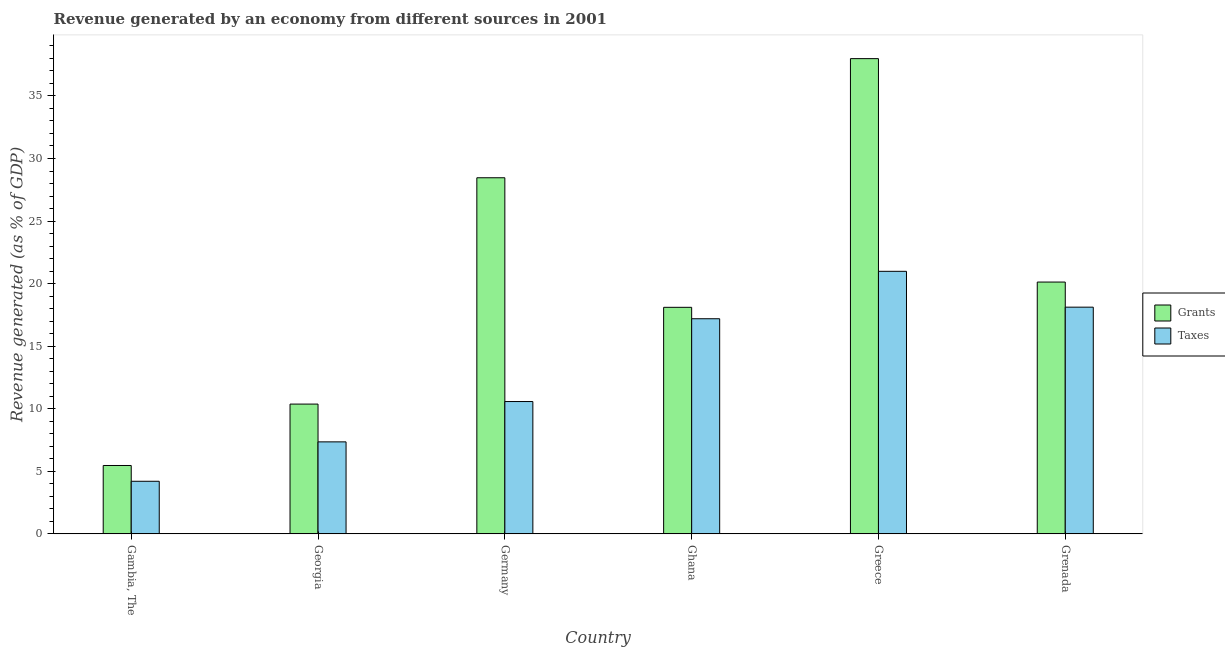How many different coloured bars are there?
Keep it short and to the point. 2. How many groups of bars are there?
Your answer should be very brief. 6. Are the number of bars per tick equal to the number of legend labels?
Make the answer very short. Yes. How many bars are there on the 5th tick from the left?
Provide a short and direct response. 2. How many bars are there on the 4th tick from the right?
Provide a succinct answer. 2. What is the label of the 5th group of bars from the left?
Your answer should be very brief. Greece. In how many cases, is the number of bars for a given country not equal to the number of legend labels?
Offer a terse response. 0. What is the revenue generated by grants in Grenada?
Offer a terse response. 20.13. Across all countries, what is the maximum revenue generated by taxes?
Offer a very short reply. 20.98. Across all countries, what is the minimum revenue generated by taxes?
Your answer should be very brief. 4.2. In which country was the revenue generated by taxes maximum?
Offer a very short reply. Greece. In which country was the revenue generated by taxes minimum?
Offer a terse response. Gambia, The. What is the total revenue generated by taxes in the graph?
Keep it short and to the point. 78.43. What is the difference between the revenue generated by taxes in Gambia, The and that in Germany?
Ensure brevity in your answer.  -6.37. What is the difference between the revenue generated by grants in Grenada and the revenue generated by taxes in Greece?
Provide a short and direct response. -0.86. What is the average revenue generated by grants per country?
Provide a succinct answer. 20.08. What is the difference between the revenue generated by taxes and revenue generated by grants in Greece?
Offer a terse response. -17. In how many countries, is the revenue generated by grants greater than 3 %?
Ensure brevity in your answer.  6. What is the ratio of the revenue generated by grants in Gambia, The to that in Georgia?
Keep it short and to the point. 0.53. What is the difference between the highest and the second highest revenue generated by grants?
Give a very brief answer. 9.52. What is the difference between the highest and the lowest revenue generated by taxes?
Keep it short and to the point. 16.78. Is the sum of the revenue generated by taxes in Greece and Grenada greater than the maximum revenue generated by grants across all countries?
Offer a terse response. Yes. What does the 1st bar from the left in Germany represents?
Provide a short and direct response. Grants. What does the 1st bar from the right in Grenada represents?
Your answer should be compact. Taxes. How many bars are there?
Offer a terse response. 12. How many countries are there in the graph?
Provide a succinct answer. 6. What is the difference between two consecutive major ticks on the Y-axis?
Give a very brief answer. 5. Does the graph contain any zero values?
Your answer should be very brief. No. What is the title of the graph?
Offer a terse response. Revenue generated by an economy from different sources in 2001. Does "Commercial service exports" appear as one of the legend labels in the graph?
Provide a succinct answer. No. What is the label or title of the Y-axis?
Offer a very short reply. Revenue generated (as % of GDP). What is the Revenue generated (as % of GDP) of Grants in Gambia, The?
Offer a very short reply. 5.46. What is the Revenue generated (as % of GDP) in Taxes in Gambia, The?
Provide a short and direct response. 4.2. What is the Revenue generated (as % of GDP) of Grants in Georgia?
Provide a short and direct response. 10.37. What is the Revenue generated (as % of GDP) in Taxes in Georgia?
Your answer should be compact. 7.35. What is the Revenue generated (as % of GDP) of Grants in Germany?
Offer a very short reply. 28.46. What is the Revenue generated (as % of GDP) of Taxes in Germany?
Your answer should be very brief. 10.58. What is the Revenue generated (as % of GDP) of Grants in Ghana?
Your answer should be very brief. 18.11. What is the Revenue generated (as % of GDP) of Taxes in Ghana?
Make the answer very short. 17.19. What is the Revenue generated (as % of GDP) in Grants in Greece?
Provide a short and direct response. 37.98. What is the Revenue generated (as % of GDP) in Taxes in Greece?
Provide a short and direct response. 20.98. What is the Revenue generated (as % of GDP) of Grants in Grenada?
Make the answer very short. 20.13. What is the Revenue generated (as % of GDP) of Taxes in Grenada?
Offer a very short reply. 18.12. Across all countries, what is the maximum Revenue generated (as % of GDP) in Grants?
Offer a very short reply. 37.98. Across all countries, what is the maximum Revenue generated (as % of GDP) of Taxes?
Give a very brief answer. 20.98. Across all countries, what is the minimum Revenue generated (as % of GDP) in Grants?
Your answer should be very brief. 5.46. Across all countries, what is the minimum Revenue generated (as % of GDP) in Taxes?
Offer a terse response. 4.2. What is the total Revenue generated (as % of GDP) of Grants in the graph?
Offer a terse response. 120.51. What is the total Revenue generated (as % of GDP) in Taxes in the graph?
Make the answer very short. 78.43. What is the difference between the Revenue generated (as % of GDP) of Grants in Gambia, The and that in Georgia?
Offer a very short reply. -4.91. What is the difference between the Revenue generated (as % of GDP) in Taxes in Gambia, The and that in Georgia?
Your response must be concise. -3.15. What is the difference between the Revenue generated (as % of GDP) in Grants in Gambia, The and that in Germany?
Your answer should be compact. -23. What is the difference between the Revenue generated (as % of GDP) in Taxes in Gambia, The and that in Germany?
Keep it short and to the point. -6.37. What is the difference between the Revenue generated (as % of GDP) in Grants in Gambia, The and that in Ghana?
Provide a short and direct response. -12.64. What is the difference between the Revenue generated (as % of GDP) of Taxes in Gambia, The and that in Ghana?
Provide a short and direct response. -12.99. What is the difference between the Revenue generated (as % of GDP) of Grants in Gambia, The and that in Greece?
Offer a very short reply. -32.52. What is the difference between the Revenue generated (as % of GDP) of Taxes in Gambia, The and that in Greece?
Your answer should be very brief. -16.78. What is the difference between the Revenue generated (as % of GDP) of Grants in Gambia, The and that in Grenada?
Provide a succinct answer. -14.66. What is the difference between the Revenue generated (as % of GDP) in Taxes in Gambia, The and that in Grenada?
Your answer should be compact. -13.91. What is the difference between the Revenue generated (as % of GDP) of Grants in Georgia and that in Germany?
Offer a terse response. -18.09. What is the difference between the Revenue generated (as % of GDP) in Taxes in Georgia and that in Germany?
Your response must be concise. -3.22. What is the difference between the Revenue generated (as % of GDP) in Grants in Georgia and that in Ghana?
Ensure brevity in your answer.  -7.73. What is the difference between the Revenue generated (as % of GDP) in Taxes in Georgia and that in Ghana?
Offer a terse response. -9.84. What is the difference between the Revenue generated (as % of GDP) of Grants in Georgia and that in Greece?
Your response must be concise. -27.61. What is the difference between the Revenue generated (as % of GDP) of Taxes in Georgia and that in Greece?
Your answer should be very brief. -13.63. What is the difference between the Revenue generated (as % of GDP) of Grants in Georgia and that in Grenada?
Give a very brief answer. -9.75. What is the difference between the Revenue generated (as % of GDP) in Taxes in Georgia and that in Grenada?
Offer a terse response. -10.77. What is the difference between the Revenue generated (as % of GDP) of Grants in Germany and that in Ghana?
Offer a terse response. 10.35. What is the difference between the Revenue generated (as % of GDP) of Taxes in Germany and that in Ghana?
Your response must be concise. -6.62. What is the difference between the Revenue generated (as % of GDP) of Grants in Germany and that in Greece?
Your answer should be compact. -9.52. What is the difference between the Revenue generated (as % of GDP) in Taxes in Germany and that in Greece?
Provide a short and direct response. -10.41. What is the difference between the Revenue generated (as % of GDP) in Grants in Germany and that in Grenada?
Your answer should be compact. 8.34. What is the difference between the Revenue generated (as % of GDP) of Taxes in Germany and that in Grenada?
Offer a terse response. -7.54. What is the difference between the Revenue generated (as % of GDP) of Grants in Ghana and that in Greece?
Your answer should be compact. -19.88. What is the difference between the Revenue generated (as % of GDP) in Taxes in Ghana and that in Greece?
Offer a very short reply. -3.79. What is the difference between the Revenue generated (as % of GDP) of Grants in Ghana and that in Grenada?
Your answer should be very brief. -2.02. What is the difference between the Revenue generated (as % of GDP) in Taxes in Ghana and that in Grenada?
Your answer should be compact. -0.93. What is the difference between the Revenue generated (as % of GDP) in Grants in Greece and that in Grenada?
Keep it short and to the point. 17.86. What is the difference between the Revenue generated (as % of GDP) of Taxes in Greece and that in Grenada?
Your answer should be very brief. 2.86. What is the difference between the Revenue generated (as % of GDP) of Grants in Gambia, The and the Revenue generated (as % of GDP) of Taxes in Georgia?
Ensure brevity in your answer.  -1.89. What is the difference between the Revenue generated (as % of GDP) in Grants in Gambia, The and the Revenue generated (as % of GDP) in Taxes in Germany?
Provide a short and direct response. -5.11. What is the difference between the Revenue generated (as % of GDP) of Grants in Gambia, The and the Revenue generated (as % of GDP) of Taxes in Ghana?
Provide a short and direct response. -11.73. What is the difference between the Revenue generated (as % of GDP) in Grants in Gambia, The and the Revenue generated (as % of GDP) in Taxes in Greece?
Keep it short and to the point. -15.52. What is the difference between the Revenue generated (as % of GDP) of Grants in Gambia, The and the Revenue generated (as % of GDP) of Taxes in Grenada?
Ensure brevity in your answer.  -12.65. What is the difference between the Revenue generated (as % of GDP) of Grants in Georgia and the Revenue generated (as % of GDP) of Taxes in Germany?
Offer a very short reply. -0.2. What is the difference between the Revenue generated (as % of GDP) in Grants in Georgia and the Revenue generated (as % of GDP) in Taxes in Ghana?
Your answer should be compact. -6.82. What is the difference between the Revenue generated (as % of GDP) in Grants in Georgia and the Revenue generated (as % of GDP) in Taxes in Greece?
Provide a short and direct response. -10.61. What is the difference between the Revenue generated (as % of GDP) of Grants in Georgia and the Revenue generated (as % of GDP) of Taxes in Grenada?
Your response must be concise. -7.75. What is the difference between the Revenue generated (as % of GDP) in Grants in Germany and the Revenue generated (as % of GDP) in Taxes in Ghana?
Give a very brief answer. 11.27. What is the difference between the Revenue generated (as % of GDP) of Grants in Germany and the Revenue generated (as % of GDP) of Taxes in Greece?
Ensure brevity in your answer.  7.48. What is the difference between the Revenue generated (as % of GDP) in Grants in Germany and the Revenue generated (as % of GDP) in Taxes in Grenada?
Ensure brevity in your answer.  10.34. What is the difference between the Revenue generated (as % of GDP) in Grants in Ghana and the Revenue generated (as % of GDP) in Taxes in Greece?
Your answer should be compact. -2.88. What is the difference between the Revenue generated (as % of GDP) in Grants in Ghana and the Revenue generated (as % of GDP) in Taxes in Grenada?
Keep it short and to the point. -0.01. What is the difference between the Revenue generated (as % of GDP) of Grants in Greece and the Revenue generated (as % of GDP) of Taxes in Grenada?
Offer a very short reply. 19.86. What is the average Revenue generated (as % of GDP) in Grants per country?
Make the answer very short. 20.08. What is the average Revenue generated (as % of GDP) of Taxes per country?
Ensure brevity in your answer.  13.07. What is the difference between the Revenue generated (as % of GDP) in Grants and Revenue generated (as % of GDP) in Taxes in Gambia, The?
Keep it short and to the point. 1.26. What is the difference between the Revenue generated (as % of GDP) of Grants and Revenue generated (as % of GDP) of Taxes in Georgia?
Your response must be concise. 3.02. What is the difference between the Revenue generated (as % of GDP) of Grants and Revenue generated (as % of GDP) of Taxes in Germany?
Ensure brevity in your answer.  17.88. What is the difference between the Revenue generated (as % of GDP) in Grants and Revenue generated (as % of GDP) in Taxes in Ghana?
Offer a terse response. 0.91. What is the difference between the Revenue generated (as % of GDP) in Grants and Revenue generated (as % of GDP) in Taxes in Greece?
Your answer should be compact. 17. What is the difference between the Revenue generated (as % of GDP) in Grants and Revenue generated (as % of GDP) in Taxes in Grenada?
Make the answer very short. 2.01. What is the ratio of the Revenue generated (as % of GDP) in Grants in Gambia, The to that in Georgia?
Your answer should be compact. 0.53. What is the ratio of the Revenue generated (as % of GDP) in Taxes in Gambia, The to that in Georgia?
Your response must be concise. 0.57. What is the ratio of the Revenue generated (as % of GDP) of Grants in Gambia, The to that in Germany?
Offer a very short reply. 0.19. What is the ratio of the Revenue generated (as % of GDP) of Taxes in Gambia, The to that in Germany?
Provide a succinct answer. 0.4. What is the ratio of the Revenue generated (as % of GDP) of Grants in Gambia, The to that in Ghana?
Give a very brief answer. 0.3. What is the ratio of the Revenue generated (as % of GDP) in Taxes in Gambia, The to that in Ghana?
Offer a very short reply. 0.24. What is the ratio of the Revenue generated (as % of GDP) in Grants in Gambia, The to that in Greece?
Offer a terse response. 0.14. What is the ratio of the Revenue generated (as % of GDP) in Taxes in Gambia, The to that in Greece?
Your answer should be very brief. 0.2. What is the ratio of the Revenue generated (as % of GDP) in Grants in Gambia, The to that in Grenada?
Your response must be concise. 0.27. What is the ratio of the Revenue generated (as % of GDP) of Taxes in Gambia, The to that in Grenada?
Keep it short and to the point. 0.23. What is the ratio of the Revenue generated (as % of GDP) of Grants in Georgia to that in Germany?
Make the answer very short. 0.36. What is the ratio of the Revenue generated (as % of GDP) of Taxes in Georgia to that in Germany?
Offer a very short reply. 0.7. What is the ratio of the Revenue generated (as % of GDP) of Grants in Georgia to that in Ghana?
Your answer should be very brief. 0.57. What is the ratio of the Revenue generated (as % of GDP) of Taxes in Georgia to that in Ghana?
Make the answer very short. 0.43. What is the ratio of the Revenue generated (as % of GDP) of Grants in Georgia to that in Greece?
Offer a very short reply. 0.27. What is the ratio of the Revenue generated (as % of GDP) in Taxes in Georgia to that in Greece?
Keep it short and to the point. 0.35. What is the ratio of the Revenue generated (as % of GDP) in Grants in Georgia to that in Grenada?
Provide a succinct answer. 0.52. What is the ratio of the Revenue generated (as % of GDP) of Taxes in Georgia to that in Grenada?
Your answer should be compact. 0.41. What is the ratio of the Revenue generated (as % of GDP) of Grants in Germany to that in Ghana?
Provide a short and direct response. 1.57. What is the ratio of the Revenue generated (as % of GDP) in Taxes in Germany to that in Ghana?
Provide a succinct answer. 0.62. What is the ratio of the Revenue generated (as % of GDP) of Grants in Germany to that in Greece?
Your response must be concise. 0.75. What is the ratio of the Revenue generated (as % of GDP) in Taxes in Germany to that in Greece?
Offer a very short reply. 0.5. What is the ratio of the Revenue generated (as % of GDP) of Grants in Germany to that in Grenada?
Offer a terse response. 1.41. What is the ratio of the Revenue generated (as % of GDP) of Taxes in Germany to that in Grenada?
Your answer should be very brief. 0.58. What is the ratio of the Revenue generated (as % of GDP) in Grants in Ghana to that in Greece?
Offer a very short reply. 0.48. What is the ratio of the Revenue generated (as % of GDP) of Taxes in Ghana to that in Greece?
Ensure brevity in your answer.  0.82. What is the ratio of the Revenue generated (as % of GDP) in Grants in Ghana to that in Grenada?
Provide a short and direct response. 0.9. What is the ratio of the Revenue generated (as % of GDP) in Taxes in Ghana to that in Grenada?
Provide a succinct answer. 0.95. What is the ratio of the Revenue generated (as % of GDP) in Grants in Greece to that in Grenada?
Provide a succinct answer. 1.89. What is the ratio of the Revenue generated (as % of GDP) of Taxes in Greece to that in Grenada?
Offer a terse response. 1.16. What is the difference between the highest and the second highest Revenue generated (as % of GDP) of Grants?
Offer a terse response. 9.52. What is the difference between the highest and the second highest Revenue generated (as % of GDP) in Taxes?
Provide a succinct answer. 2.86. What is the difference between the highest and the lowest Revenue generated (as % of GDP) in Grants?
Ensure brevity in your answer.  32.52. What is the difference between the highest and the lowest Revenue generated (as % of GDP) of Taxes?
Offer a very short reply. 16.78. 